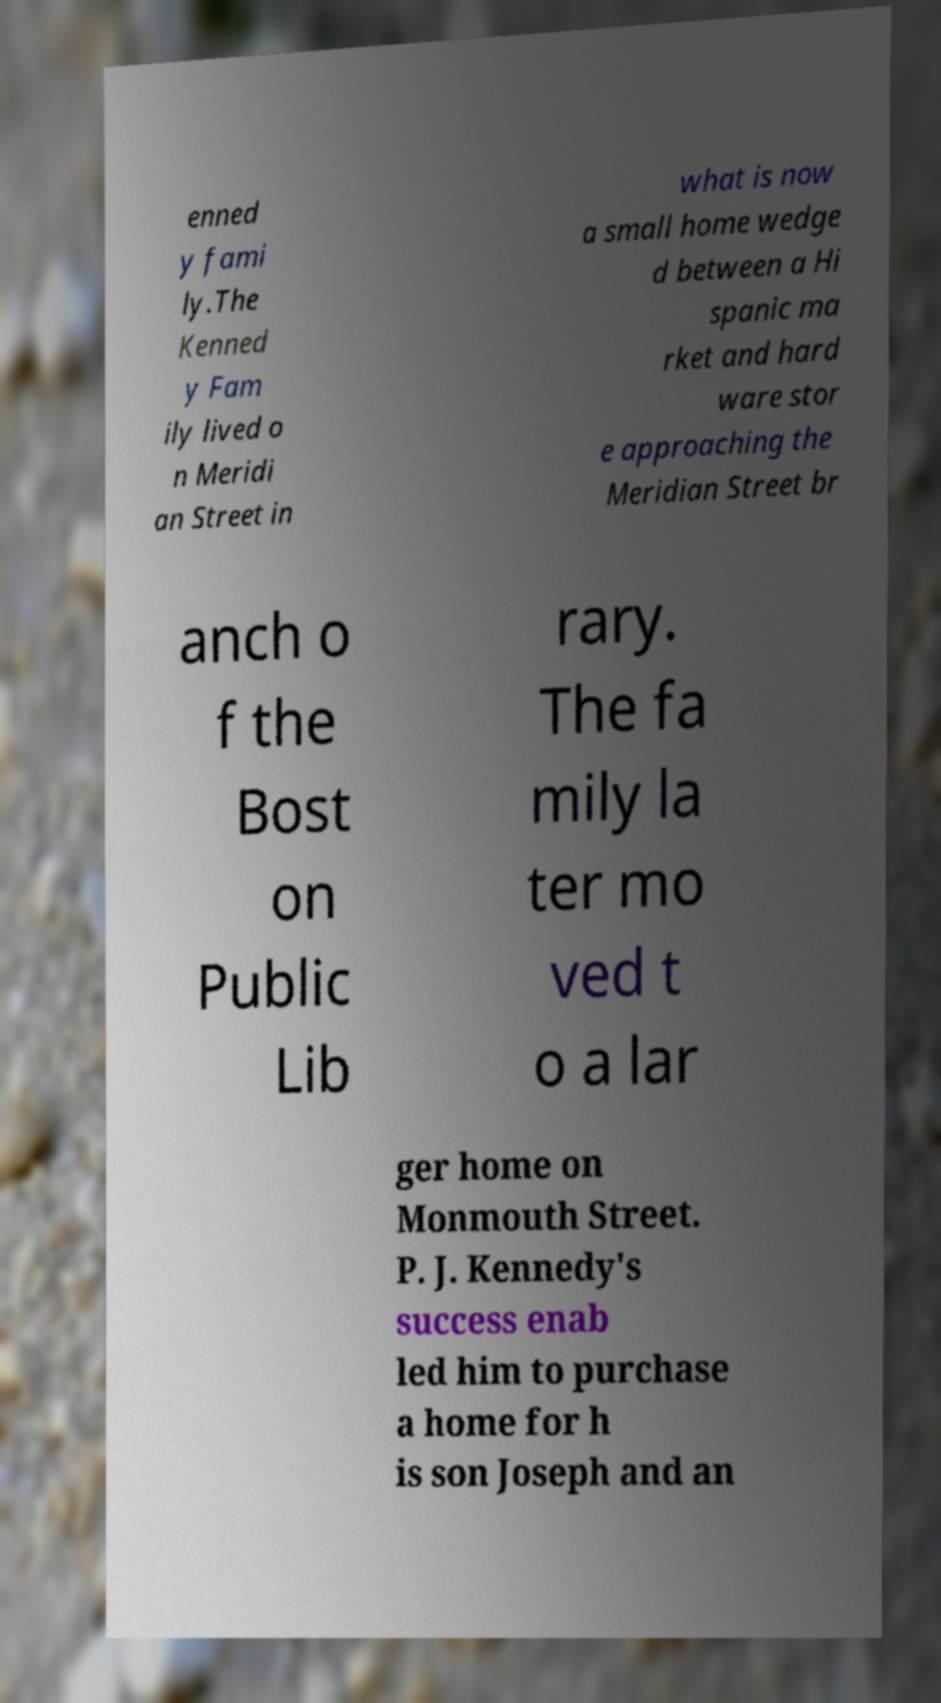Could you assist in decoding the text presented in this image and type it out clearly? enned y fami ly.The Kenned y Fam ily lived o n Meridi an Street in what is now a small home wedge d between a Hi spanic ma rket and hard ware stor e approaching the Meridian Street br anch o f the Bost on Public Lib rary. The fa mily la ter mo ved t o a lar ger home on Monmouth Street. P. J. Kennedy's success enab led him to purchase a home for h is son Joseph and an 